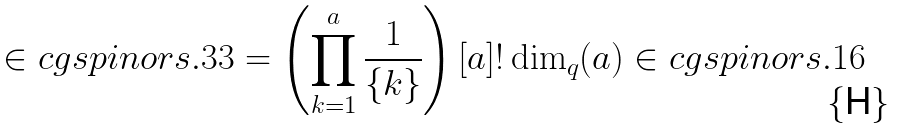<formula> <loc_0><loc_0><loc_500><loc_500>\in c g { s p i n o r s . 3 3 } = \left ( \prod _ { k = 1 } ^ { a } \frac { 1 } { \{ k \} } \right ) [ a ] ! \dim _ { q } ( a ) \in c g { s p i n o r s . 1 6 }</formula> 